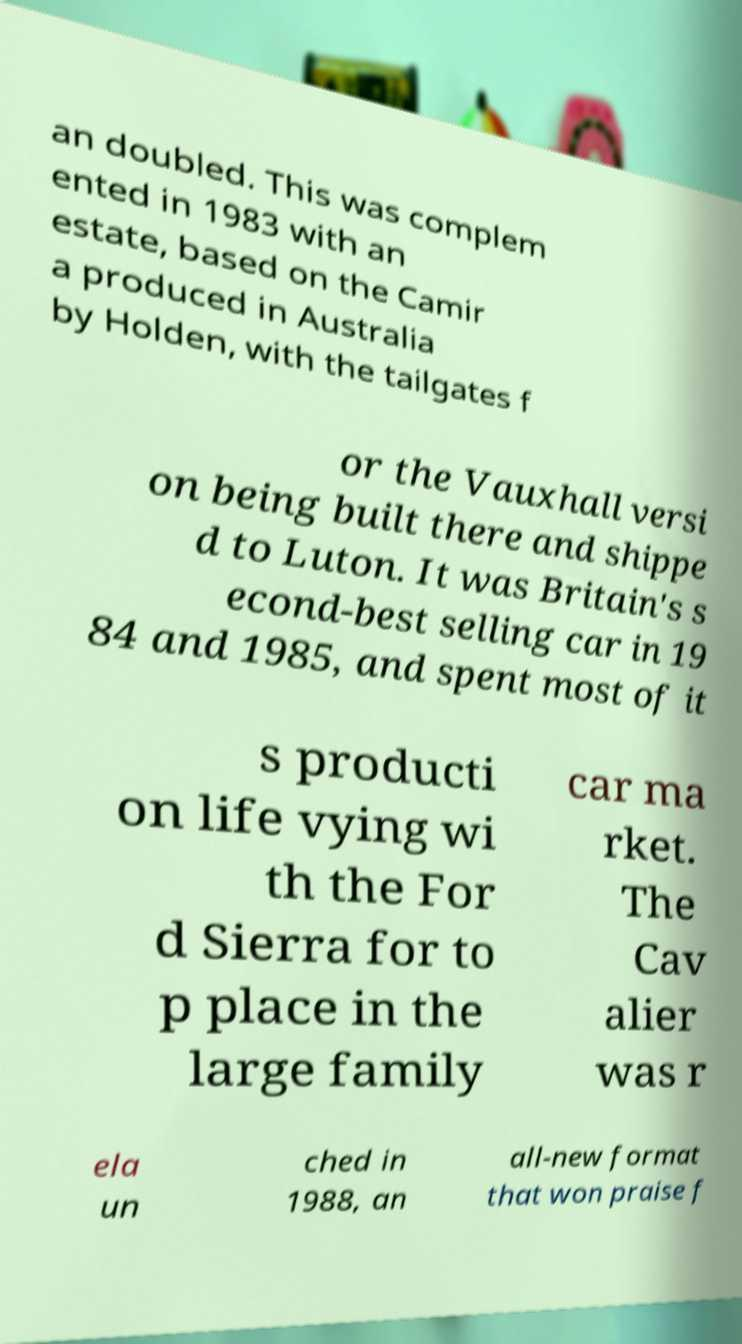For documentation purposes, I need the text within this image transcribed. Could you provide that? an doubled. This was complem ented in 1983 with an estate, based on the Camir a produced in Australia by Holden, with the tailgates f or the Vauxhall versi on being built there and shippe d to Luton. It was Britain's s econd-best selling car in 19 84 and 1985, and spent most of it s producti on life vying wi th the For d Sierra for to p place in the large family car ma rket. The Cav alier was r ela un ched in 1988, an all-new format that won praise f 